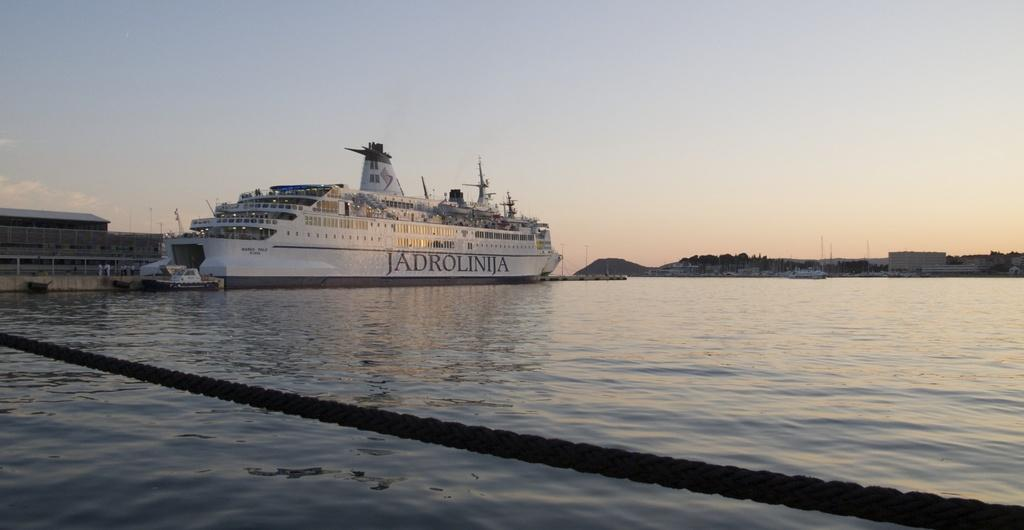What is the main subject of the picture? The main subject of the picture is a ferry. What can be seen in the water in the picture? There is water in the picture. What is visible in the background of the picture? There are buildings and a mountain in the background of the picture. What is the condition of the sky in the picture? The sky is clear in the background of the picture. How many tents can be seen in the picture? There are no tents present in the picture. What type of beast is swimming in the water next to the ferry? There is no beast present in the picture; it features a ferry in the water. 